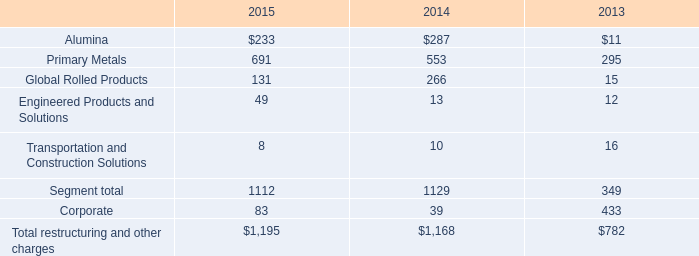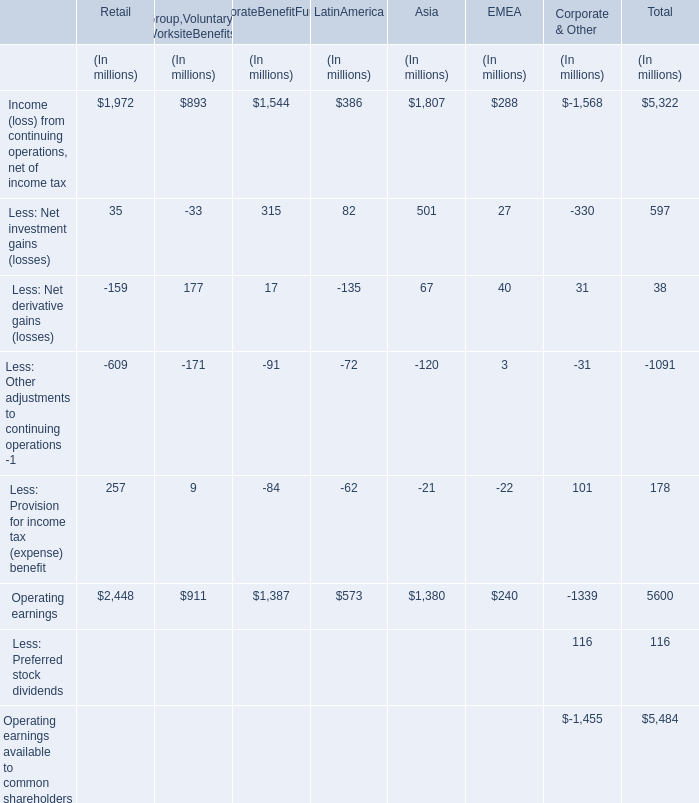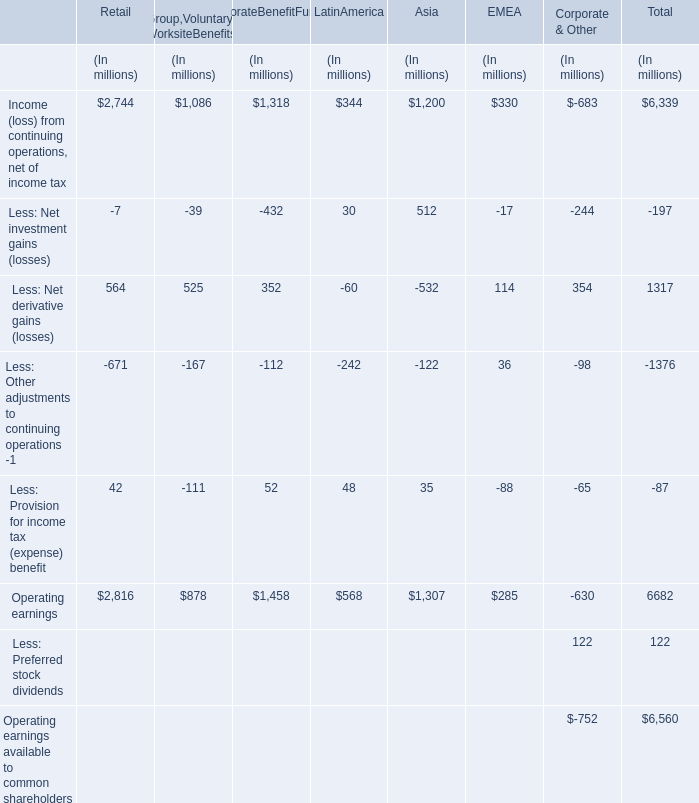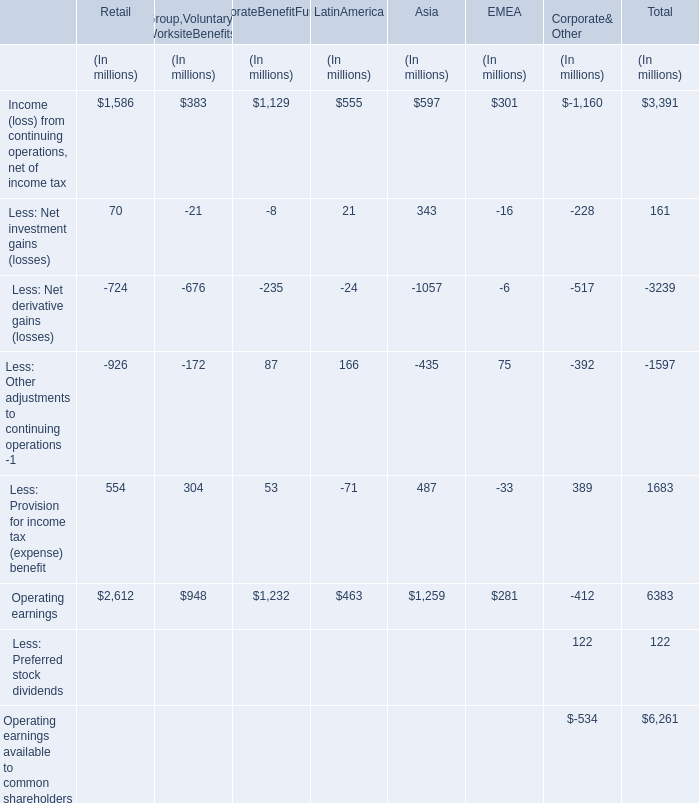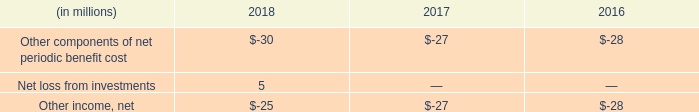From all sections expect Total,what do all Operating earnings sum up, excluding those negative ones? (in million) 
Computations: (((((2816 + 878) + 1458) + 568) + 1307) + 285)
Answer: 7312.0. 